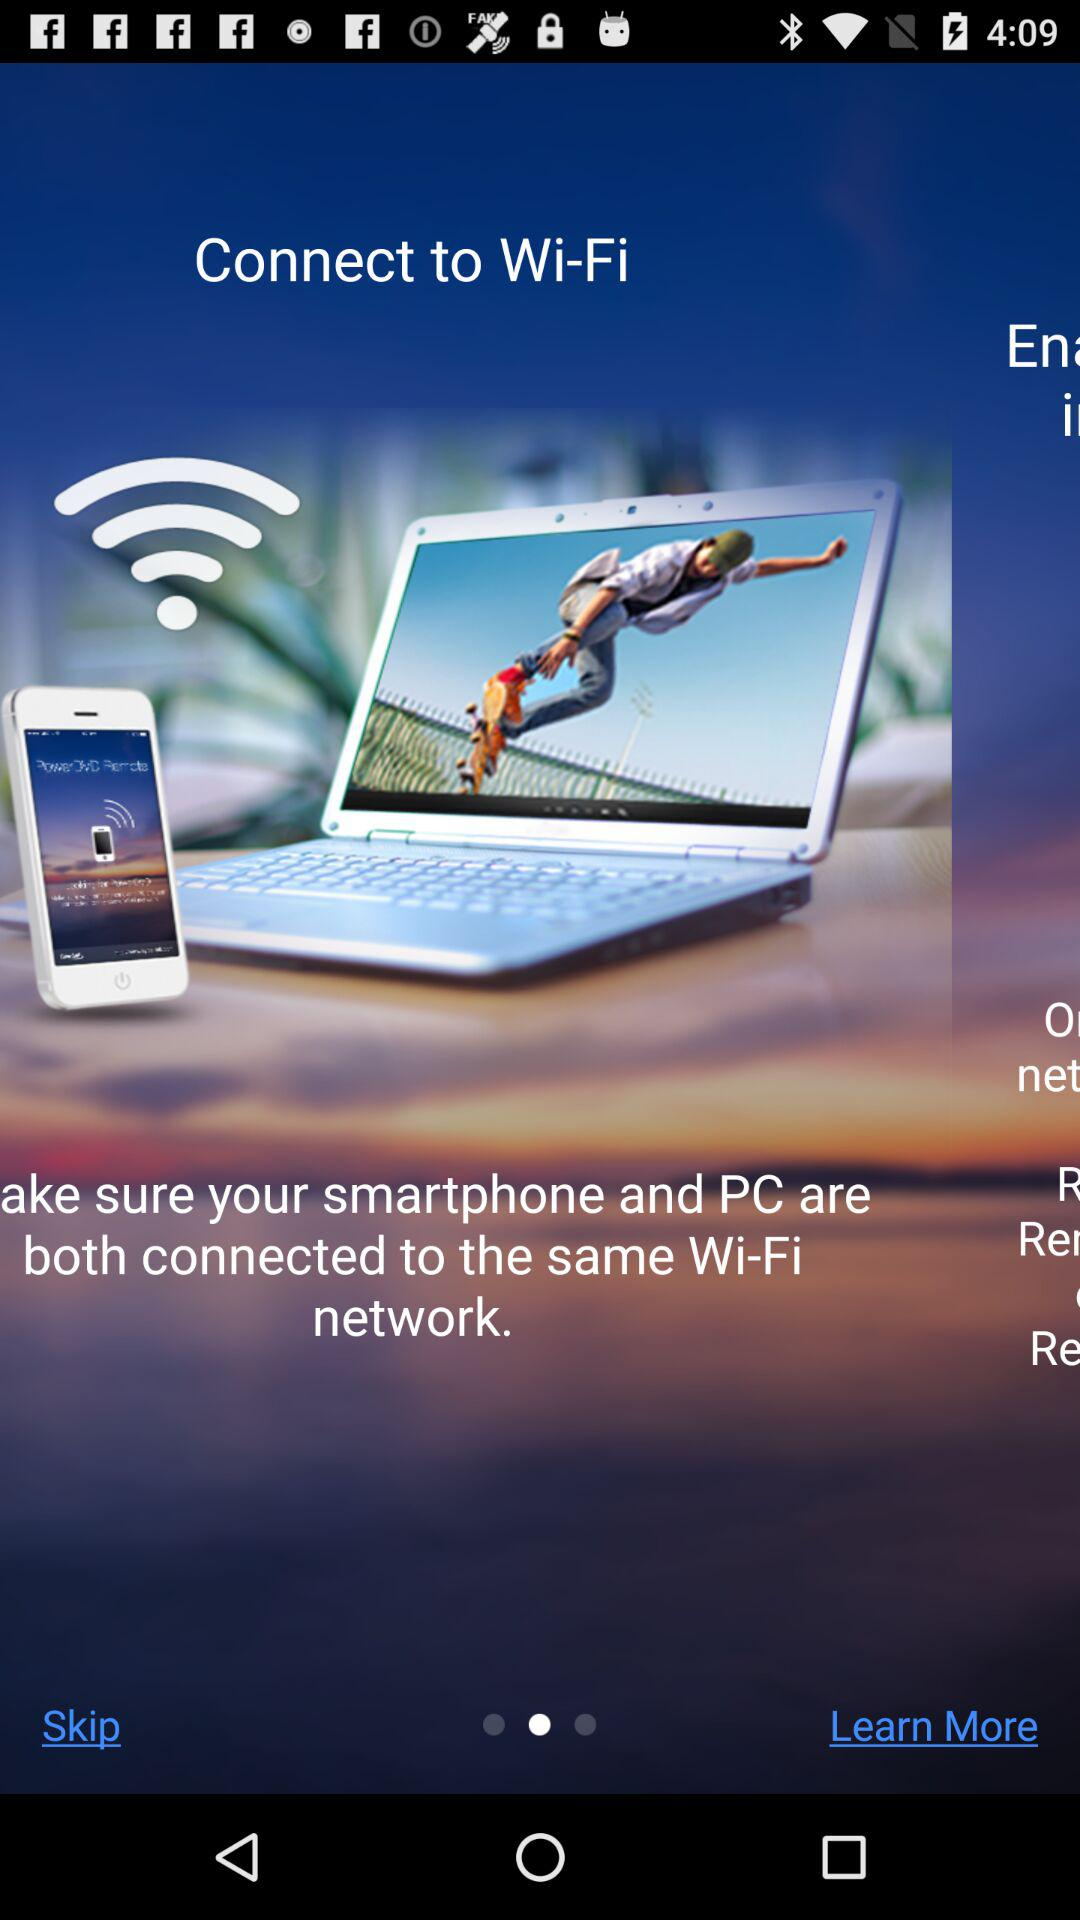How many more 'R's are there than 'E's in the text on this screen?
Answer the question using a single word or phrase. 2 